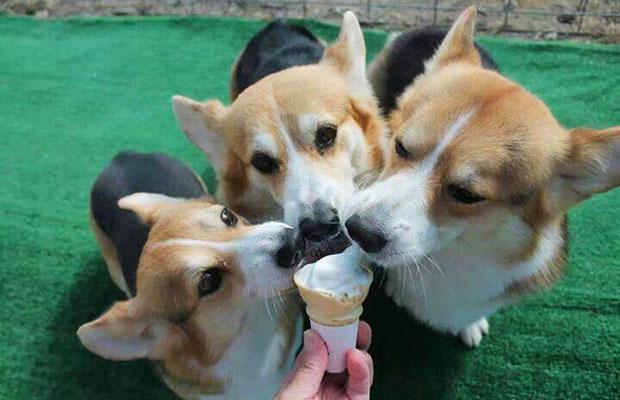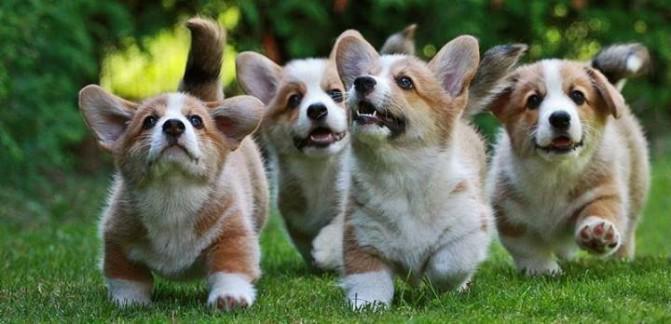The first image is the image on the left, the second image is the image on the right. Analyze the images presented: Is the assertion "There are no more than 7 dogs in total." valid? Answer yes or no. Yes. 